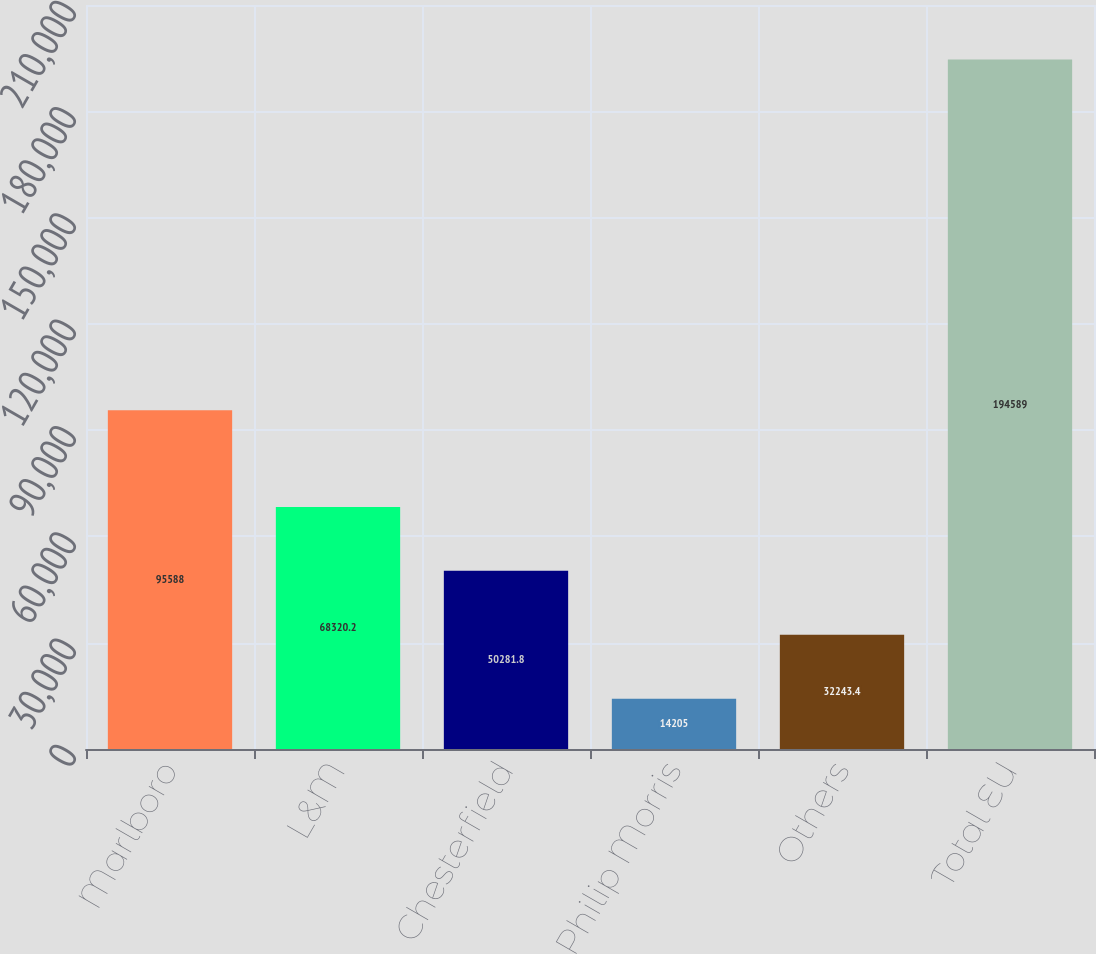Convert chart to OTSL. <chart><loc_0><loc_0><loc_500><loc_500><bar_chart><fcel>Marlboro<fcel>L&M<fcel>Chesterfield<fcel>Philip Morris<fcel>Others<fcel>Total EU<nl><fcel>95588<fcel>68320.2<fcel>50281.8<fcel>14205<fcel>32243.4<fcel>194589<nl></chart> 